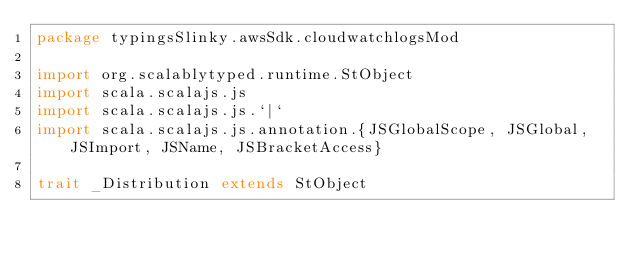Convert code to text. <code><loc_0><loc_0><loc_500><loc_500><_Scala_>package typingsSlinky.awsSdk.cloudwatchlogsMod

import org.scalablytyped.runtime.StObject
import scala.scalajs.js
import scala.scalajs.js.`|`
import scala.scalajs.js.annotation.{JSGlobalScope, JSGlobal, JSImport, JSName, JSBracketAccess}

trait _Distribution extends StObject
</code> 